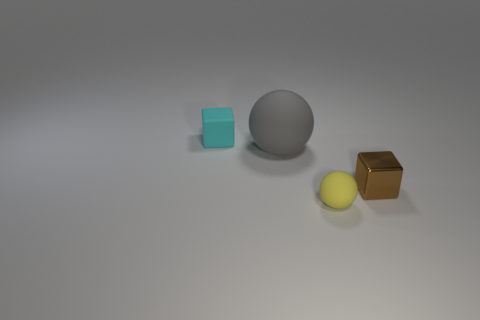Add 1 red metallic cylinders. How many objects exist? 5 Subtract all purple cylinders. How many brown blocks are left? 1 Subtract all big gray balls. Subtract all tiny brown objects. How many objects are left? 2 Add 4 yellow balls. How many yellow balls are left? 5 Add 1 small cyan matte things. How many small cyan matte things exist? 2 Subtract all yellow spheres. How many spheres are left? 1 Subtract 0 blue cubes. How many objects are left? 4 Subtract all brown blocks. Subtract all red cylinders. How many blocks are left? 1 